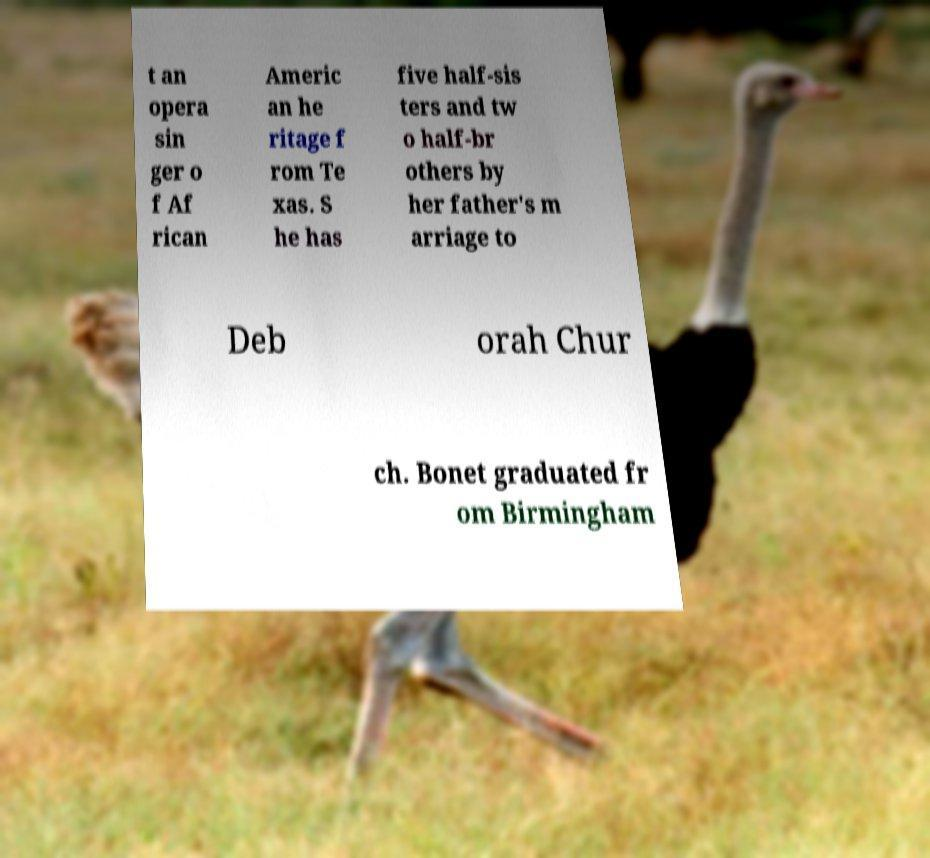Please identify and transcribe the text found in this image. t an opera sin ger o f Af rican Americ an he ritage f rom Te xas. S he has five half-sis ters and tw o half-br others by her father's m arriage to Deb orah Chur ch. Bonet graduated fr om Birmingham 